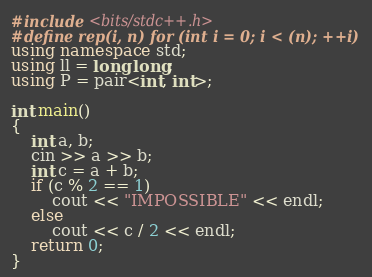<code> <loc_0><loc_0><loc_500><loc_500><_C++_>#include <bits/stdc++.h>
#define rep(i, n) for (int i = 0; i < (n); ++i)
using namespace std;
using ll = long long;
using P = pair<int, int>;

int main()
{
    int a, b;
    cin >> a >> b;
    int c = a + b;
    if (c % 2 == 1)
        cout << "IMPOSSIBLE" << endl;
    else
        cout << c / 2 << endl;
    return 0;
}</code> 